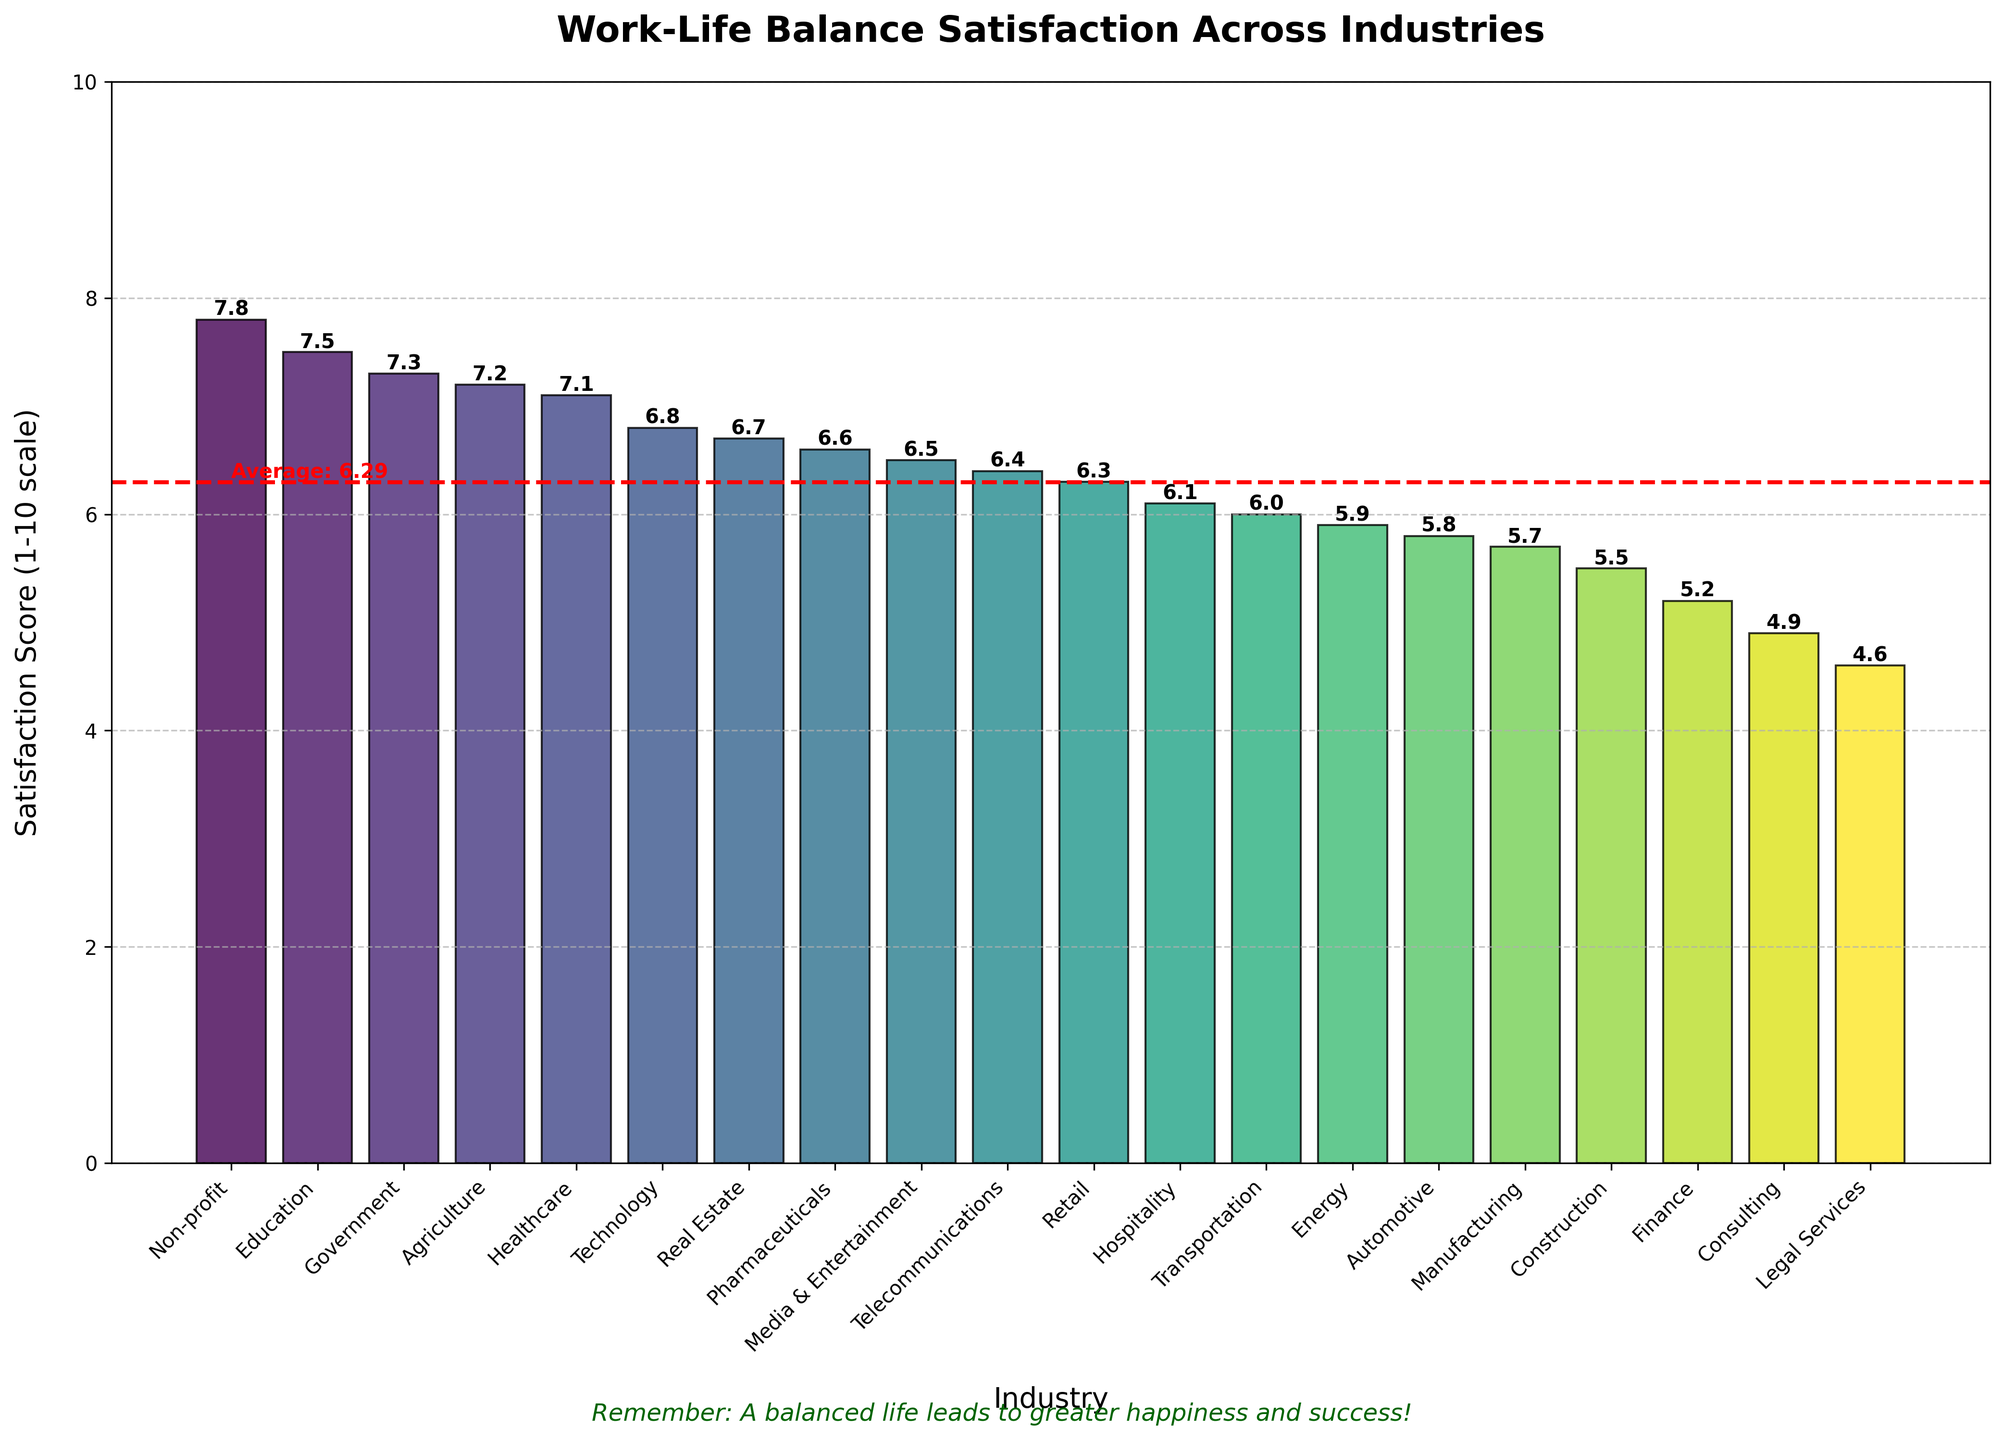Which industry has the highest work-life balance satisfaction? Look at the bar chart and identify the tallest bar, which represents the highest satisfaction score. The industry with the highest score is Non-profit with a score of 7.8.
Answer: Non-profit Which industry has the lowest work-life balance satisfaction? Look at the bar chart and identify the shortest bar, which represents the lowest satisfaction score. The industry with the lowest score is Legal Services with a score of 4.6.
Answer: Legal Services How does the satisfaction score for Technology compare to Finance? Find the bars for Technology and Finance. The height of the Technology bar (6.8) is compared to the Finance bar (5.2). Technology has a higher satisfaction score than Finance.
Answer: Technology has a higher score What is the average work-life balance satisfaction score across all industries? The average score is indicated by a horizontal red dashed line. The label next to the line shows the average score of 6.3.
Answer: 6.3 Which industries have a satisfaction score higher than the average? Identify the industries with bars taller than the red dashed line. These industries are Non-profit, Agriculture, Education, Healthcare, Government, and Technology.
Answer: Non-profit, Agriculture, Education, Healthcare, Government, Technology What is the difference between the highest and lowest satisfaction scores? Subtract the lowest satisfaction score (4.6, Legal Services) from the highest satisfaction score (7.8, Non-profit). The difference is 7.8 - 4.6 = 3.2.
Answer: 3.2 What is the combined satisfaction score of Healthcare and Education? Add the satisfaction scores of Healthcare (7.1) and Education (7.5). The combined score is 7.1 + 7.5 = 14.6.
Answer: 14.6 Which industry’s satisfaction score is closest to the average? Compare the satisfaction scores of all industries to the average score of 6.3. The closest industry is Retail with a score of 6.3.
Answer: Retail How many industries have a satisfaction score below 5? Count the bars with scores less than 5. The industries are Consulting (4.9) and Legal Services (4.6). So, there are 2 industries.
Answer: 2 What is the median work-life balance satisfaction score across the industries? List the satisfaction scores in ascending order and find the middle value. Since there are 20 industries, the median lies between the 10th and 11th values. The scores in order are: 4.6, 4.9, 5.2, 5.5, 5.7, 5.8, 5.9, 6.0, 6.1, 6.3, 6.4, 6.5, 6.6, 6.7, 6.8, 7.1, 7.2, 7.3, 7.5, 7.8. The median is the average of 6.3 and 6.4, which is (6.3 + 6.4) / 2 = 6.35.
Answer: 6.35 